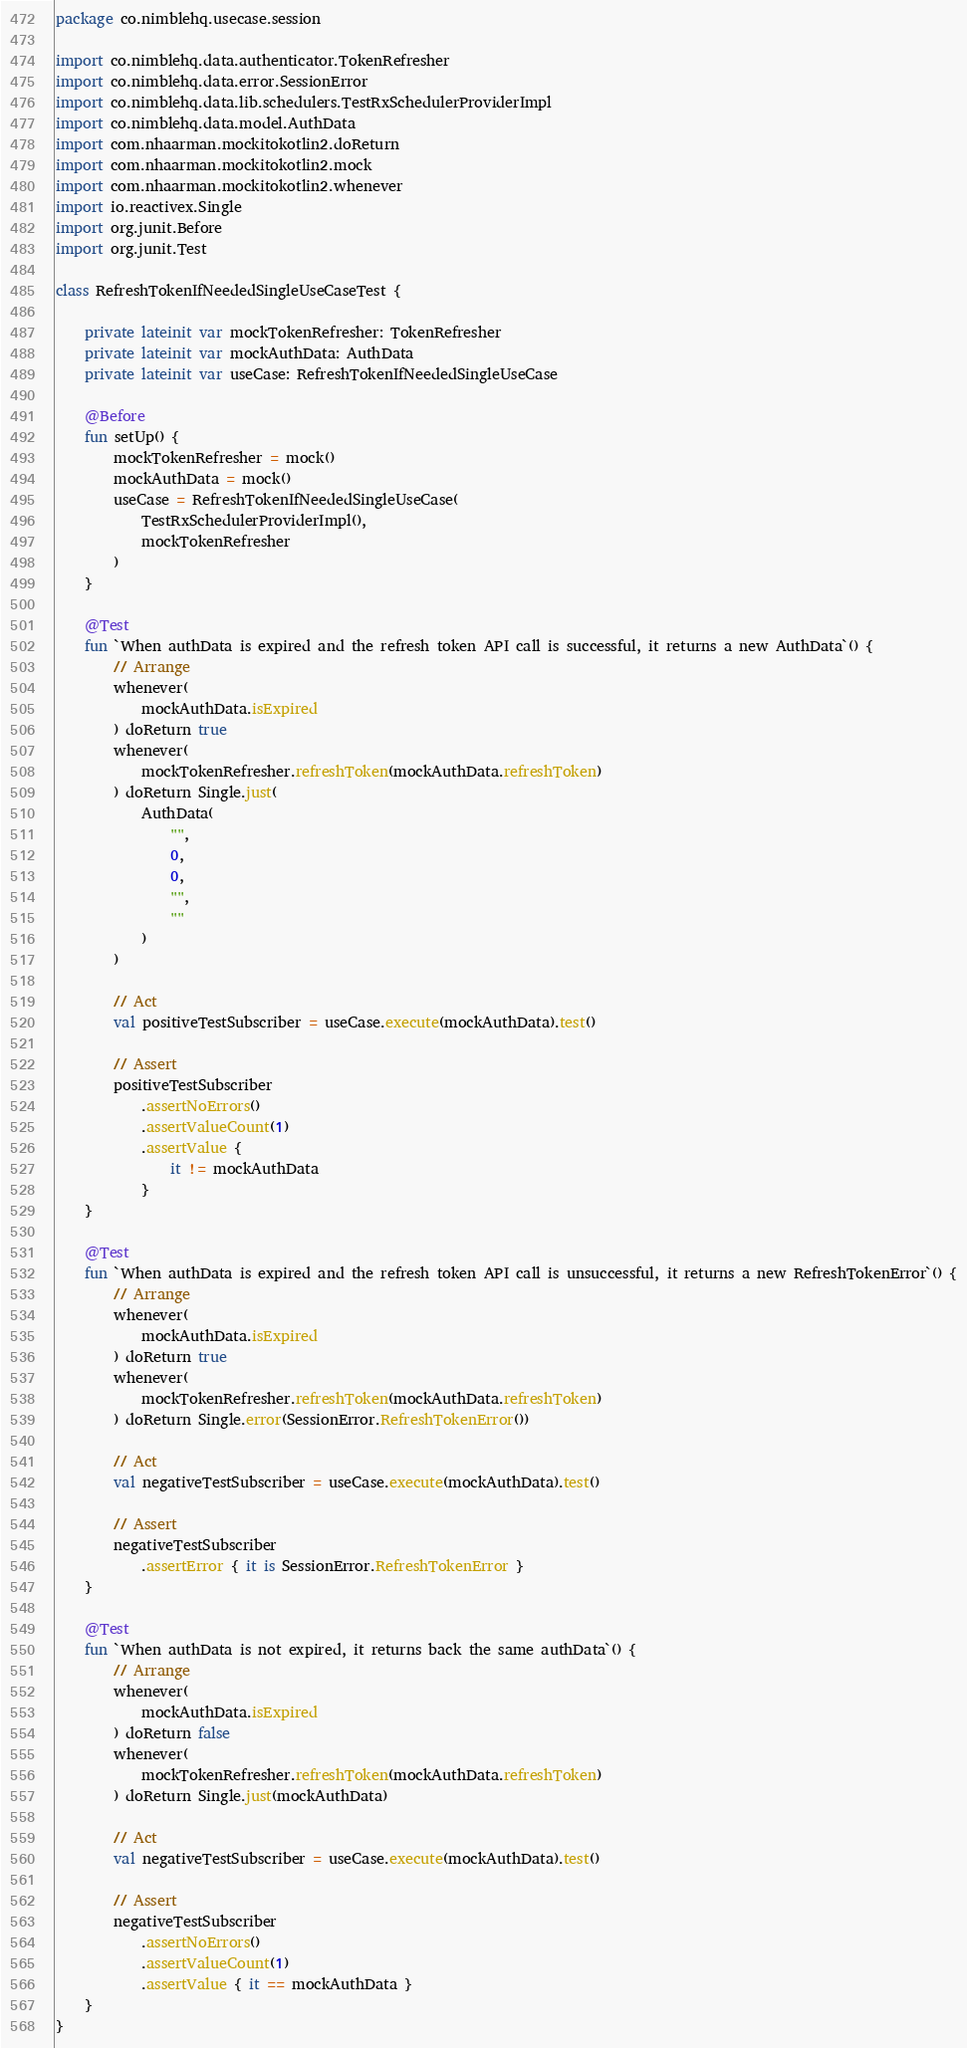<code> <loc_0><loc_0><loc_500><loc_500><_Kotlin_>package co.nimblehq.usecase.session

import co.nimblehq.data.authenticator.TokenRefresher
import co.nimblehq.data.error.SessionError
import co.nimblehq.data.lib.schedulers.TestRxSchedulerProviderImpl
import co.nimblehq.data.model.AuthData
import com.nhaarman.mockitokotlin2.doReturn
import com.nhaarman.mockitokotlin2.mock
import com.nhaarman.mockitokotlin2.whenever
import io.reactivex.Single
import org.junit.Before
import org.junit.Test

class RefreshTokenIfNeededSingleUseCaseTest {

    private lateinit var mockTokenRefresher: TokenRefresher
    private lateinit var mockAuthData: AuthData
    private lateinit var useCase: RefreshTokenIfNeededSingleUseCase

    @Before
    fun setUp() {
        mockTokenRefresher = mock()
        mockAuthData = mock()
        useCase = RefreshTokenIfNeededSingleUseCase(
            TestRxSchedulerProviderImpl(),
            mockTokenRefresher
        )
    }

    @Test
    fun `When authData is expired and the refresh token API call is successful, it returns a new AuthData`() {
        // Arrange
        whenever(
            mockAuthData.isExpired
        ) doReturn true
        whenever(
            mockTokenRefresher.refreshToken(mockAuthData.refreshToken)
        ) doReturn Single.just(
            AuthData(
                "",
                0,
                0,
                "",
                ""
            )
        )

        // Act
        val positiveTestSubscriber = useCase.execute(mockAuthData).test()

        // Assert
        positiveTestSubscriber
            .assertNoErrors()
            .assertValueCount(1)
            .assertValue {
                it != mockAuthData
            }
    }

    @Test
    fun `When authData is expired and the refresh token API call is unsuccessful, it returns a new RefreshTokenError`() {
        // Arrange
        whenever(
            mockAuthData.isExpired
        ) doReturn true
        whenever(
            mockTokenRefresher.refreshToken(mockAuthData.refreshToken)
        ) doReturn Single.error(SessionError.RefreshTokenError())

        // Act
        val negativeTestSubscriber = useCase.execute(mockAuthData).test()

        // Assert
        negativeTestSubscriber
            .assertError { it is SessionError.RefreshTokenError }
    }

    @Test
    fun `When authData is not expired, it returns back the same authData`() {
        // Arrange
        whenever(
            mockAuthData.isExpired
        ) doReturn false
        whenever(
            mockTokenRefresher.refreshToken(mockAuthData.refreshToken)
        ) doReturn Single.just(mockAuthData)

        // Act
        val negativeTestSubscriber = useCase.execute(mockAuthData).test()

        // Assert
        negativeTestSubscriber
            .assertNoErrors()
            .assertValueCount(1)
            .assertValue { it == mockAuthData }
    }
}
</code> 